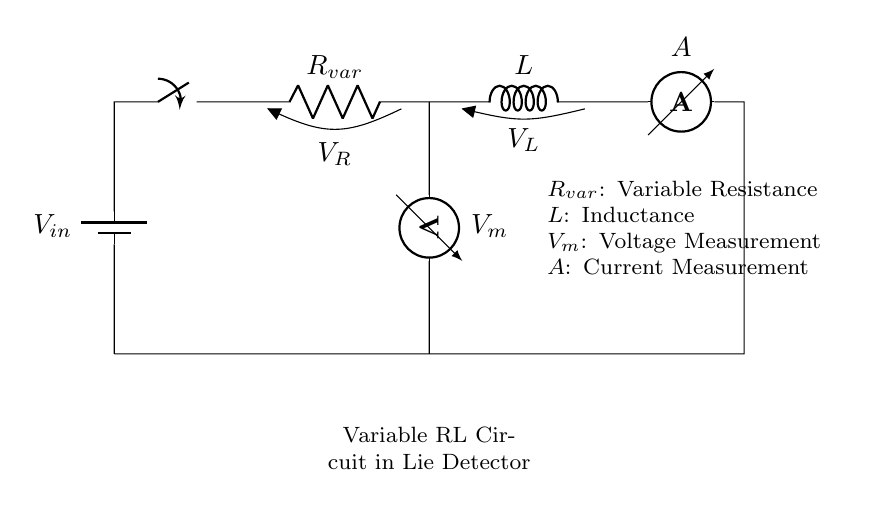What is the type of this circuit? The circuit is a variable RL circuit because it consists of a resistor and an inductor in series, with a variable resistance component.
Answer: variable RL circuit What does the variable resistance do? The variable resistance changes the total resistance in the circuit, which affects the current. It allows the operator to manipulate the circuit parameters during the lie detection process.
Answer: changes current What is measured by the ammeter? The ammeter measures the current flowing through the circuit, which is indicative of the physiological responses monitored in lie detector tests.
Answer: current What component is used to measure voltage? The voltmeter is the component used to measure the voltage across the variable resistor in this circuit.
Answer: voltmeter If the inductance is high, what happens to current? A higher inductance generally results in a slower rise in current in the circuit due to the inductor's opposition to changes in current. This is particularly relevant when interpreting physiological responses.
Answer: slower rise How does changing the resistance affect the circuit? Changing the resistance alters the current according to Ohm's Law, influencing how the inductor behaves and consequently affecting the readings in the lie detector. This is critical for analyzing truthfulness.
Answer: alters current What does the switch do in this circuit? The switch allows the operator to open or close the circuit, enabling or disabling the flow of current, which is essential during the testing phases of the interrogation.
Answer: controls current flow 